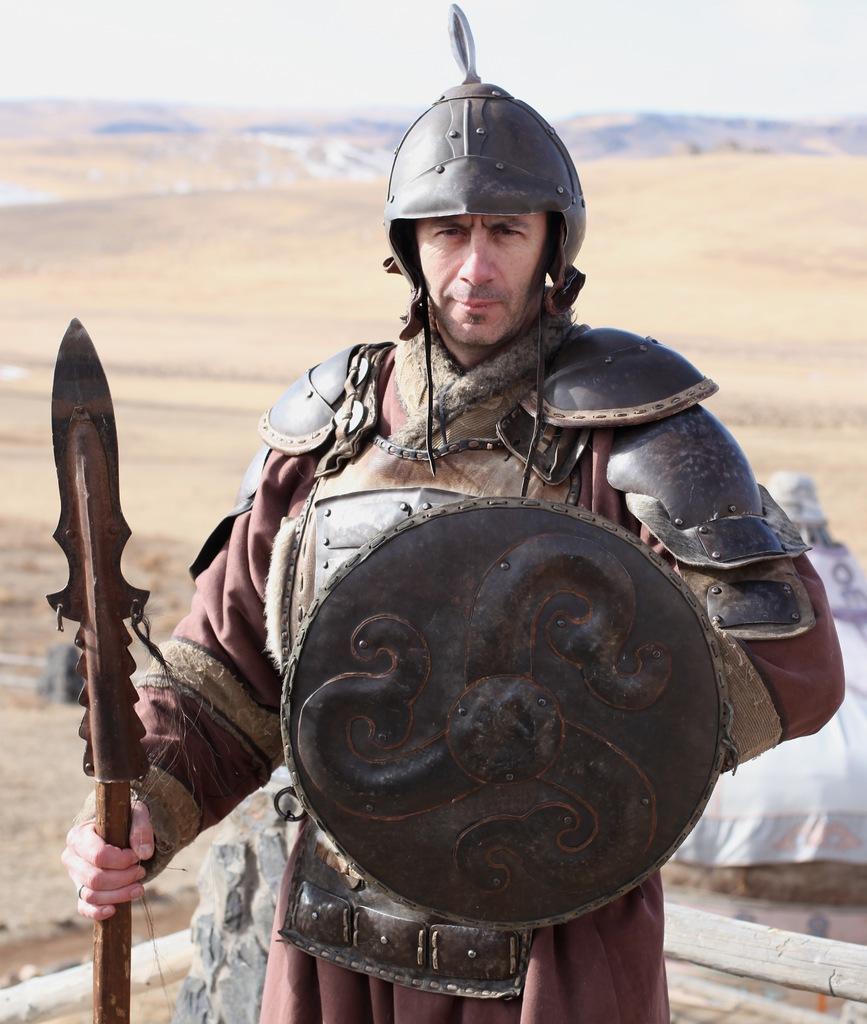How would you summarize this image in a sentence or two? In this image I can see a person standing wearing brown color dress and holding few weapons, background I can see sand in brown color and the sky is in white color. 